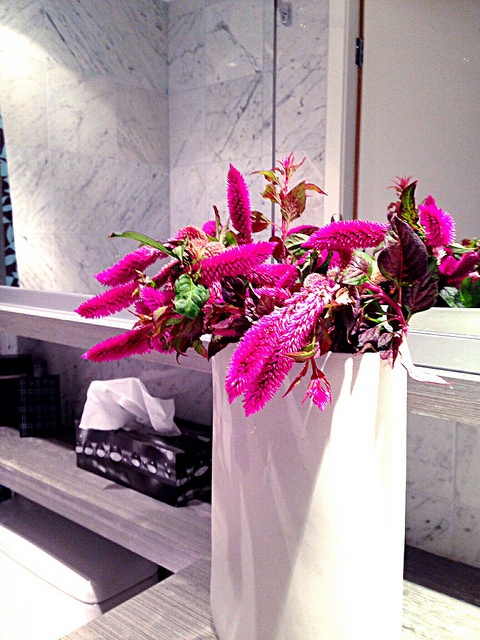Describe the objects in this image and their specific colors. I can see a vase in darkgray, white, and pink tones in this image. 